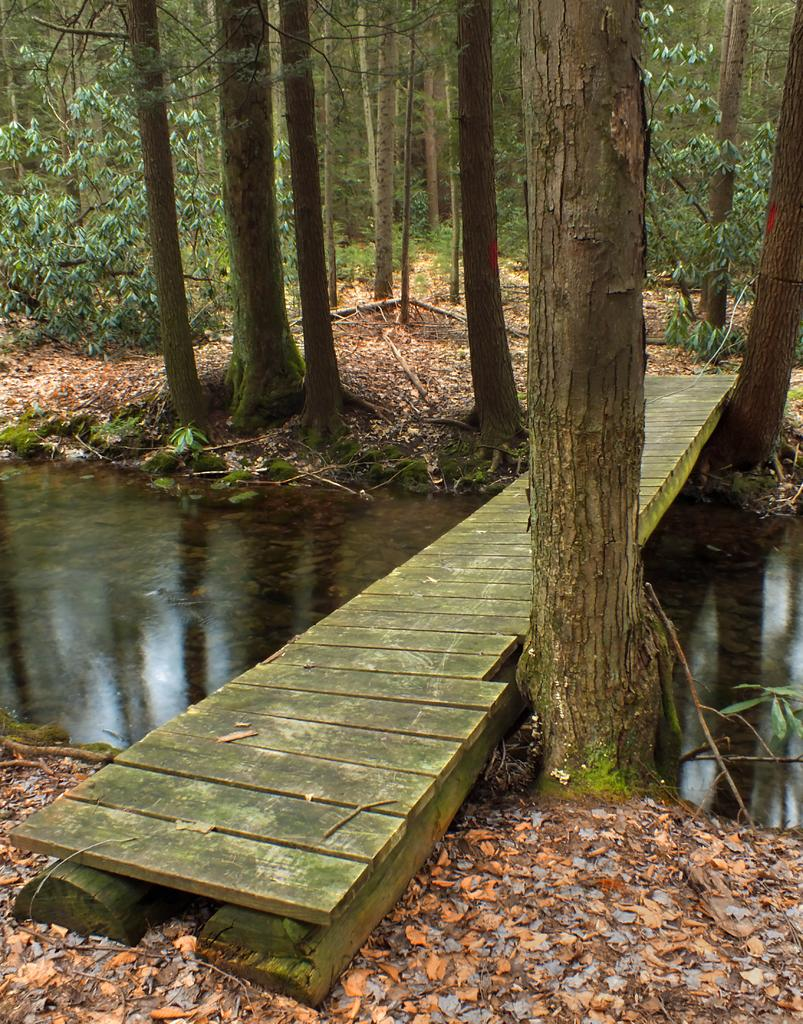What type of vegetation is visible in the image? There are trees in the image. What is present on the ground among the trees? There are dried leaves in the image. What can be seen in the image besides trees and dried leaves? There is water visible in the image. What type of path is present in the image? There is a wooden path in the image. What type of pollution can be seen in the image? There is no pollution present in the image. What type of boundary is visible in the image? There is no boundary present in the image. 